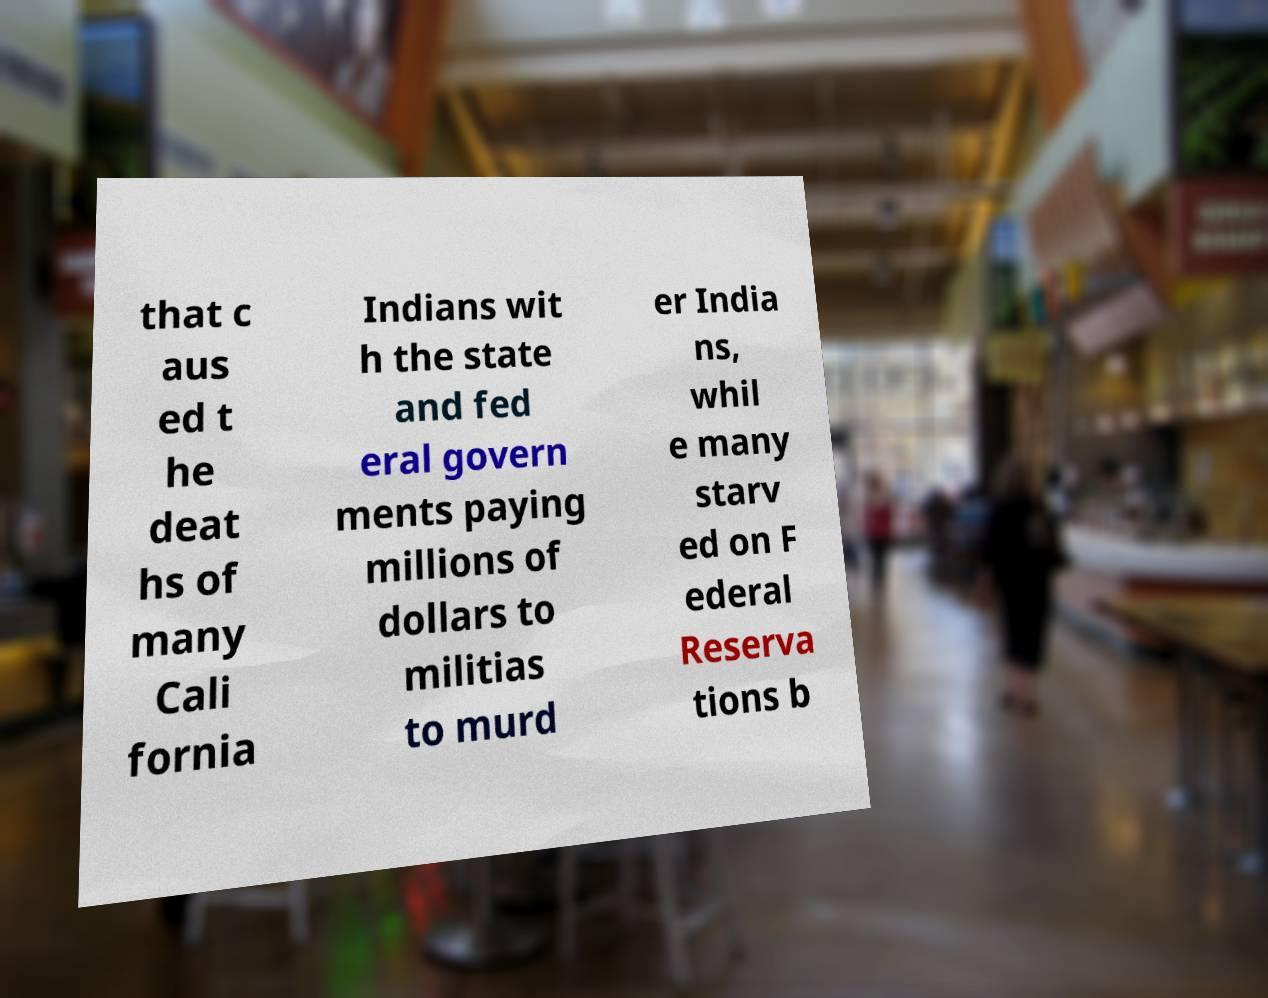Could you extract and type out the text from this image? that c aus ed t he deat hs of many Cali fornia Indians wit h the state and fed eral govern ments paying millions of dollars to militias to murd er India ns, whil e many starv ed on F ederal Reserva tions b 